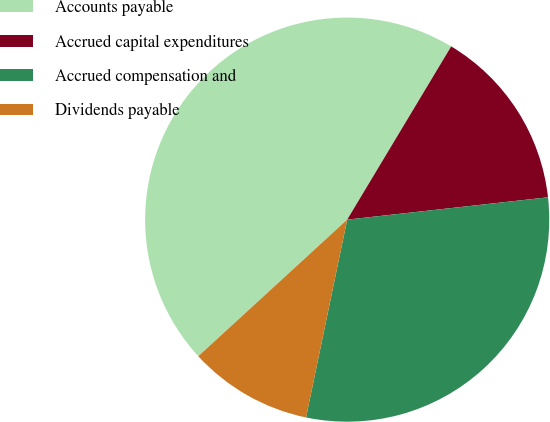Convert chart. <chart><loc_0><loc_0><loc_500><loc_500><pie_chart><fcel>Accounts payable<fcel>Accrued capital expenditures<fcel>Accrued compensation and<fcel>Dividends payable<nl><fcel>45.42%<fcel>14.63%<fcel>30.03%<fcel>9.92%<nl></chart> 